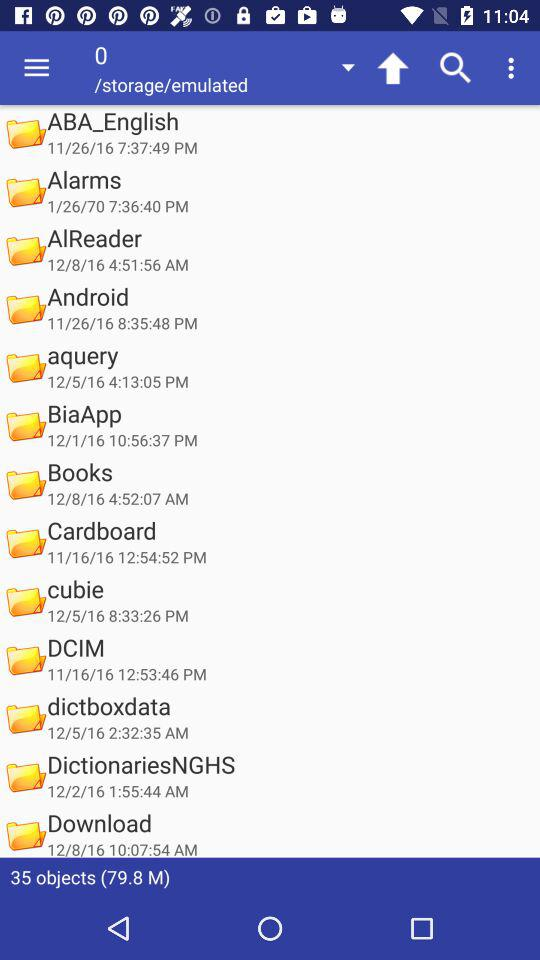On 12/2/16, which folder was created? On 12/2/16, the folder "DictionariesNGHS" was created. 